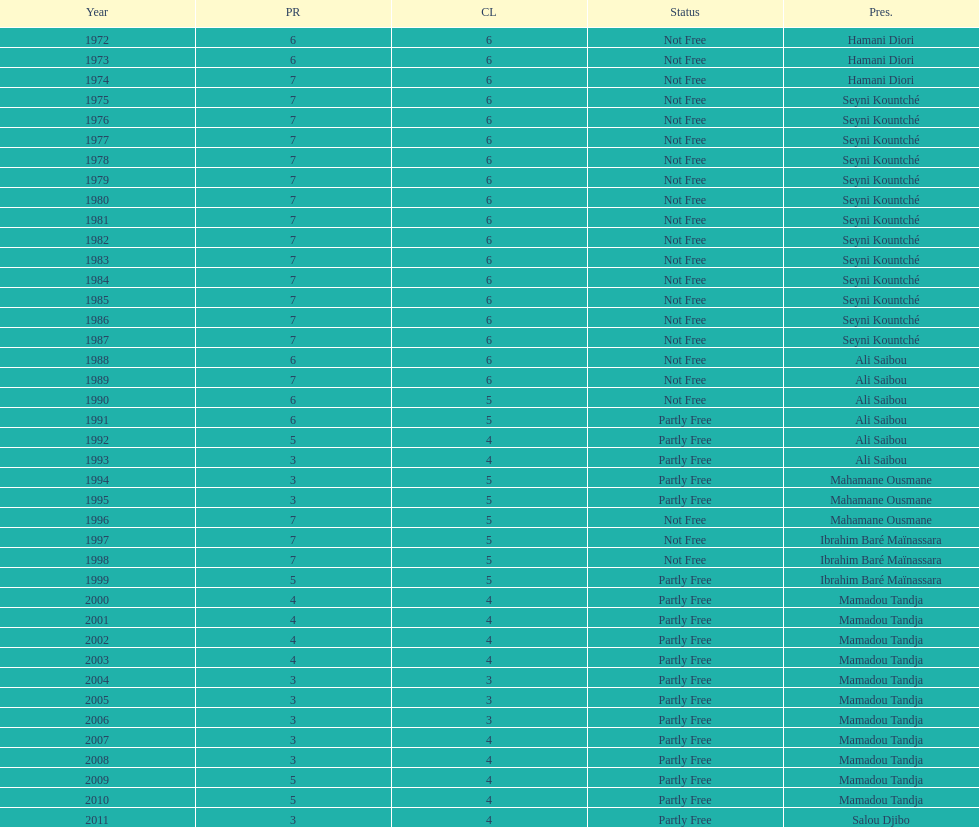In what time frame did civil liberties decline to less than 6? 18 years. 